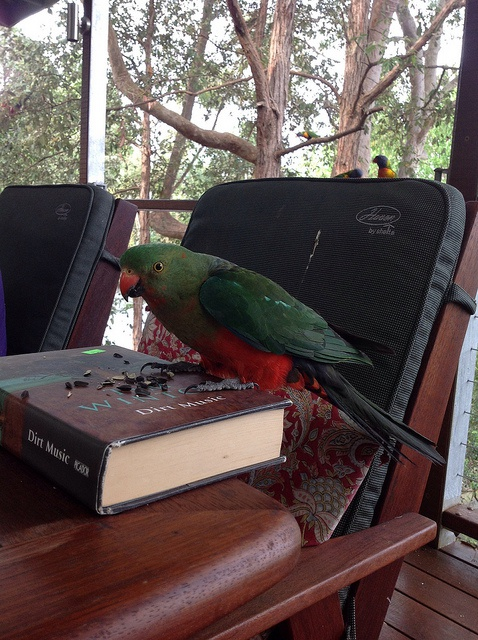Describe the objects in this image and their specific colors. I can see chair in purple, black, maroon, gray, and brown tones, book in purple, gray, black, tan, and maroon tones, bird in purple, black, maroon, gray, and darkgreen tones, chair in purple, black, and gray tones, and bird in purple, black, maroon, gray, and olive tones in this image. 